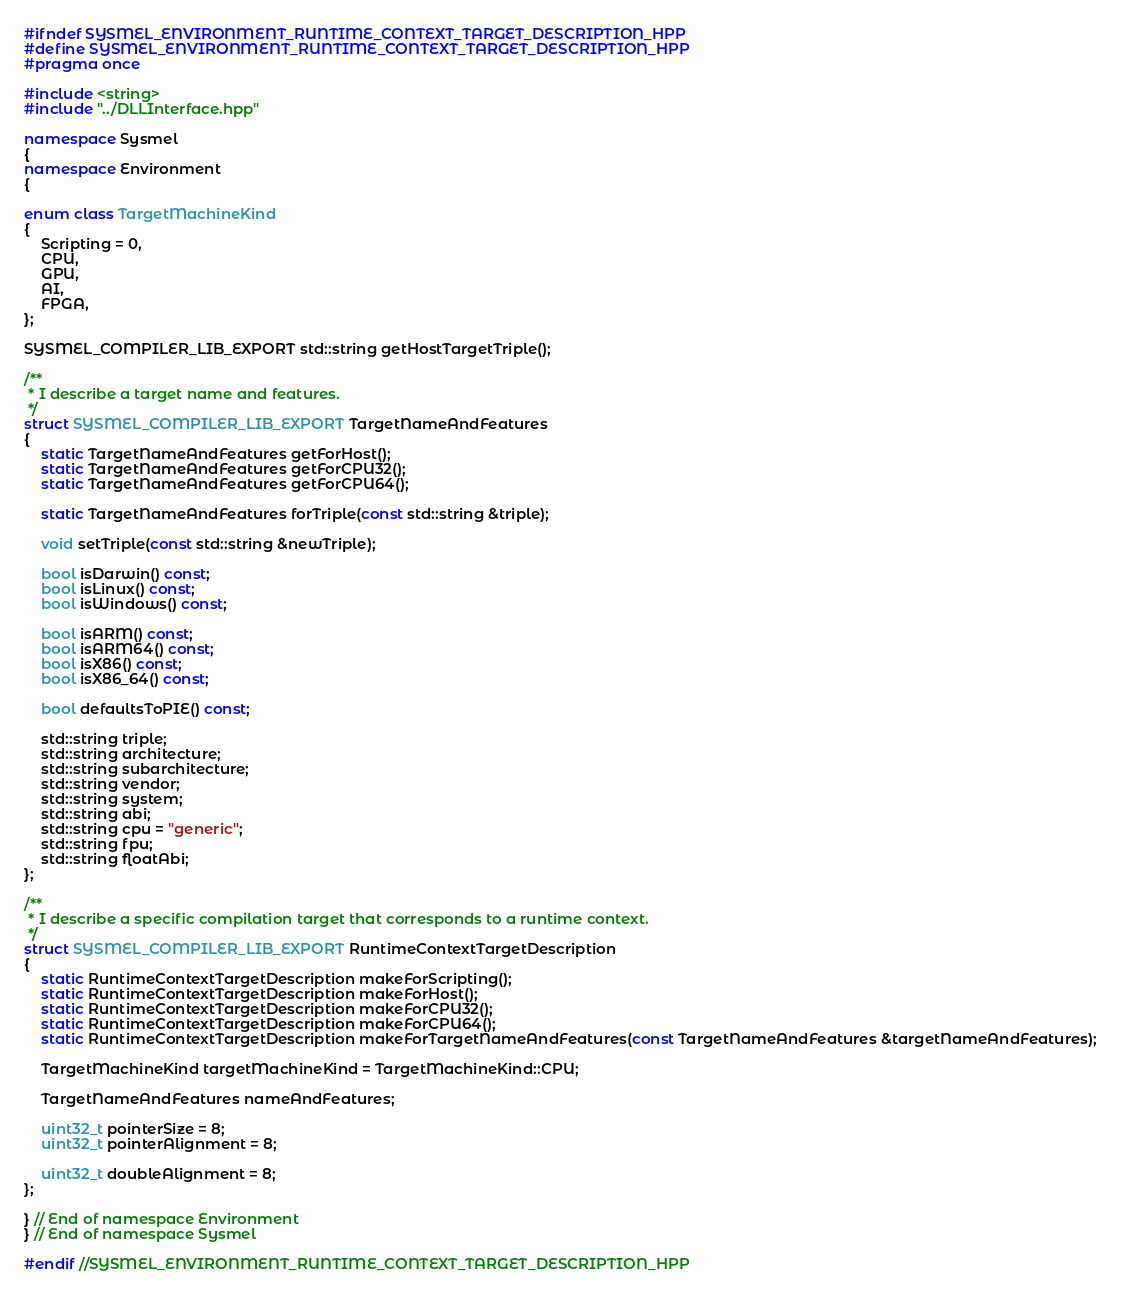Convert code to text. <code><loc_0><loc_0><loc_500><loc_500><_C++_>#ifndef SYSMEL_ENVIRONMENT_RUNTIME_CONTEXT_TARGET_DESCRIPTION_HPP
#define SYSMEL_ENVIRONMENT_RUNTIME_CONTEXT_TARGET_DESCRIPTION_HPP
#pragma once

#include <string>
#include "../DLLInterface.hpp"

namespace Sysmel
{
namespace Environment
{

enum class TargetMachineKind
{
    Scripting = 0,
    CPU,
    GPU,
    AI,
    FPGA,
};

SYSMEL_COMPILER_LIB_EXPORT std::string getHostTargetTriple();

/**
 * I describe a target name and features.
 */
struct SYSMEL_COMPILER_LIB_EXPORT TargetNameAndFeatures
{
    static TargetNameAndFeatures getForHost();
    static TargetNameAndFeatures getForCPU32();
    static TargetNameAndFeatures getForCPU64();

    static TargetNameAndFeatures forTriple(const std::string &triple);

    void setTriple(const std::string &newTriple);

    bool isDarwin() const;
    bool isLinux() const;
    bool isWindows() const;

    bool isARM() const;
    bool isARM64() const;
    bool isX86() const;
    bool isX86_64() const;

    bool defaultsToPIE() const;

    std::string triple;
    std::string architecture;
    std::string subarchitecture;
    std::string vendor;
    std::string system;
    std::string abi;
    std::string cpu = "generic";
    std::string fpu;
    std::string floatAbi;
};

/**
 * I describe a specific compilation target that corresponds to a runtime context.
 */
struct SYSMEL_COMPILER_LIB_EXPORT RuntimeContextTargetDescription
{
    static RuntimeContextTargetDescription makeForScripting();
    static RuntimeContextTargetDescription makeForHost();
    static RuntimeContextTargetDescription makeForCPU32();
    static RuntimeContextTargetDescription makeForCPU64();
    static RuntimeContextTargetDescription makeForTargetNameAndFeatures(const TargetNameAndFeatures &targetNameAndFeatures);

    TargetMachineKind targetMachineKind = TargetMachineKind::CPU;

    TargetNameAndFeatures nameAndFeatures;
    
    uint32_t pointerSize = 8;
    uint32_t pointerAlignment = 8;

    uint32_t doubleAlignment = 8;
};

} // End of namespace Environment
} // End of namespace Sysmel

#endif //SYSMEL_ENVIRONMENT_RUNTIME_CONTEXT_TARGET_DESCRIPTION_HPP</code> 